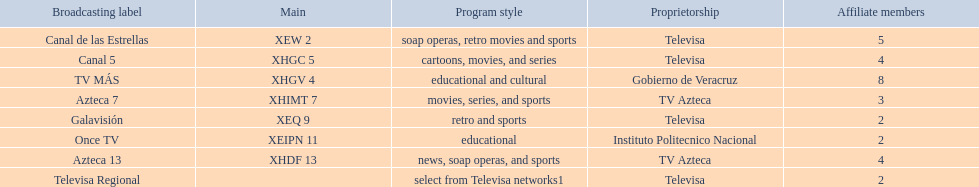Which is the only station with 8 affiliates? TV MÁS. 